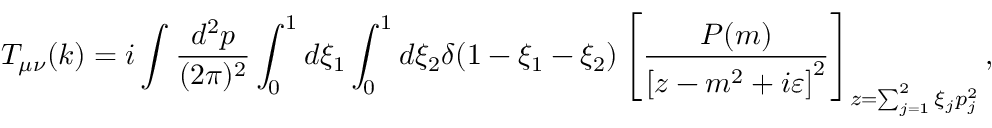Convert formula to latex. <formula><loc_0><loc_0><loc_500><loc_500>T _ { \mu \nu } ( k ) = i \int \frac { d ^ { 2 } p } { ( 2 \pi ) ^ { 2 } } \int _ { 0 } ^ { 1 } d \xi _ { 1 } \int _ { 0 } ^ { 1 } d \xi _ { 2 } \delta ( 1 - \xi _ { 1 } - \xi _ { 2 } ) \left [ \frac { P ( m ) } { \left [ z - m ^ { 2 } + i \varepsilon \right ] ^ { 2 } } \right ] _ { z = \sum _ { j = 1 } ^ { 2 } \xi _ { j } p _ { j } ^ { 2 } } ,</formula> 